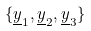Convert formula to latex. <formula><loc_0><loc_0><loc_500><loc_500>\{ \underline { y } _ { 1 } , \underline { y } _ { 2 } , \underline { y } _ { 3 } \}</formula> 